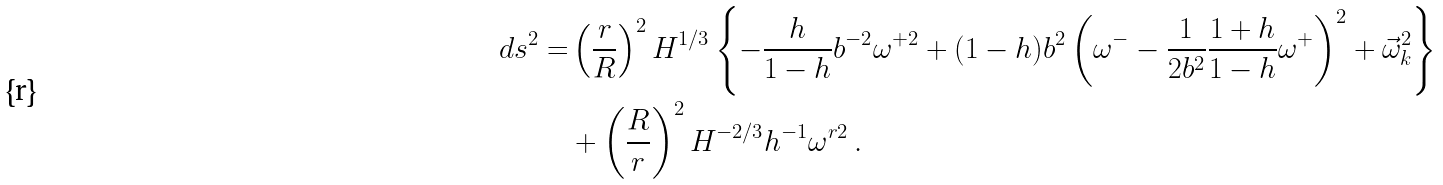Convert formula to latex. <formula><loc_0><loc_0><loc_500><loc_500>d s ^ { 2 } = & \left ( \frac { r } { R } \right ) ^ { 2 } H ^ { 1 / 3 } \left \{ - \frac { h } { 1 - h } b ^ { - 2 } \omega ^ { + 2 } + ( 1 - h ) b ^ { 2 } \left ( \omega ^ { - } - \frac { 1 } { 2 b ^ { 2 } } \frac { 1 + h } { 1 - h } \omega ^ { + } \right ) ^ { 2 } + \vec { \omega } _ { k } ^ { 2 } \right \} \\ & + \left ( \frac { R } { r } \right ) ^ { 2 } H ^ { - 2 / 3 } h ^ { - 1 } \omega ^ { r 2 } \, .</formula> 